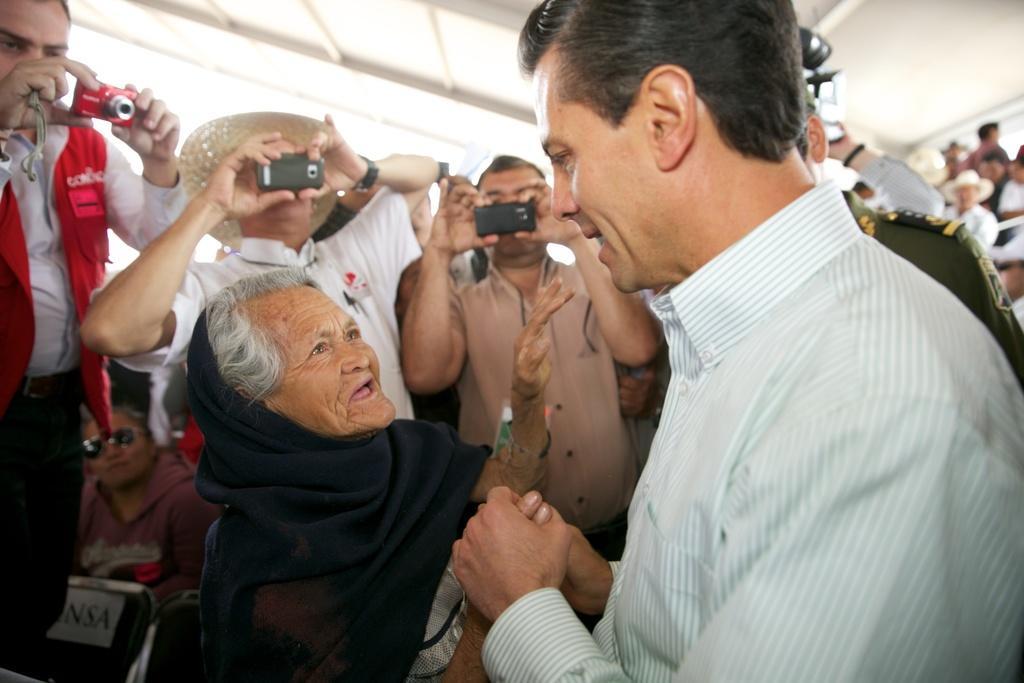Could you give a brief overview of what you see in this image? In the center of the picture there is a woman standing and talking. On the right this a man standing and holding the woman's hand. In the background there are lot of people holding mobile phones and cameras. On the top there is ceiling. 